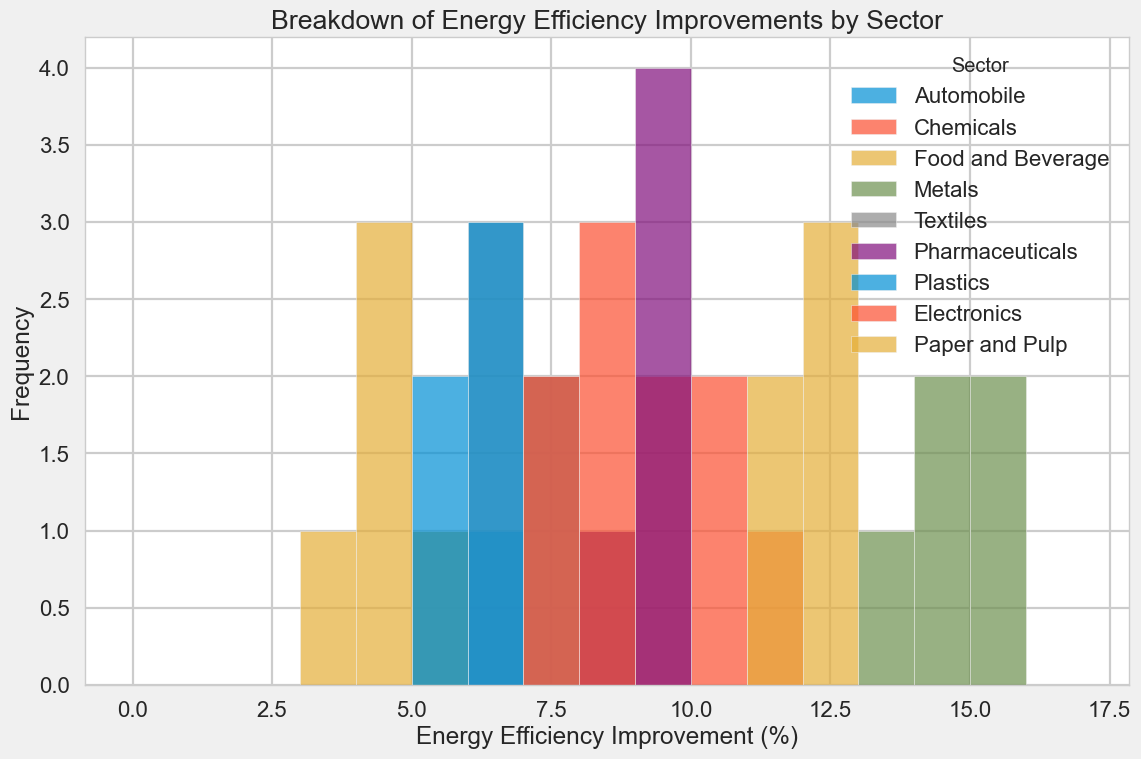What sector shows the highest peak in energy efficiency improvements? First, observe the histogram to identify which sector's bar reaches the highest frequency. The tallest peak in the histogram indicates the sector with the highest frequency of improvement.
Answer: Metals How do the energy efficiency improvements in the Automobile sector compare to those in the Pharmaceuticals sector? Look at the bars representing the Automobile (green) and Pharmaceuticals (purple) sectors. Compare their frequencies and ranges visually.
Answer: Pharmaceuticals generally have higher improvements Which sector has the most varied range of energy efficiency improvements? Compare the widths of the distributions for each sector by looking at how wide the bars are for each. The sector with the widest distribution will be the one with the most varied range.
Answer: Metals On average, is energy efficiency improvement in the Chemicals sector higher than in the Food and Beverage sector? Compare the central tendencies of the bars for Chemicals (light blue) and Food and Beverage (red). Notice the mean values visually.
Answer: Yes What is the most common range of energy efficiency improvement for the Textiles sector? Identify the tallest bars within the Textiles sector's histogram (yellow). The range near the tallest bars indicates the most common energy efficiency improvements.
Answer: 6.5-7.0% In terms of frequency, how do the energy efficiency improvements of the Plastics sector compare to that of the Paper and Pulp sector? Compare the heights of the bars representing the Plastics (orange) and Paper and Pulp (pink) sectors.
Answer: Plastics have slightly lower frequencies Which sector has the smallest average energy efficiency improvement? Identify the sector with the mode that is positioned farthest to the left on the histogram. This indicates the lowest average energy efficiency improvements.
Answer: Food and Beverage Are the majority of Metals sector improvements above 14%? Observe the positions and heights of the bars for the Metals sector. Check if most bars are situated above the 14% mark.
Answer: Yes How does the distribution of energy efficiency improvements in Electronics compare to that in Textiles? Compare the spread and frequency of bars in the Electronics (blue) and Textiles (yellow) sectors.
Answer: Electronics improvements are more concentrated around 8%, while Textiles are distributed around 6.5-7.2% What's the range of the most common energy efficiency improvement for the Electronics sector? Look for the tallest peak in the Electronics (blue) sector. The range where this peak occurs will indicate the most common improvement.
Answer: 7.8-8.5% 